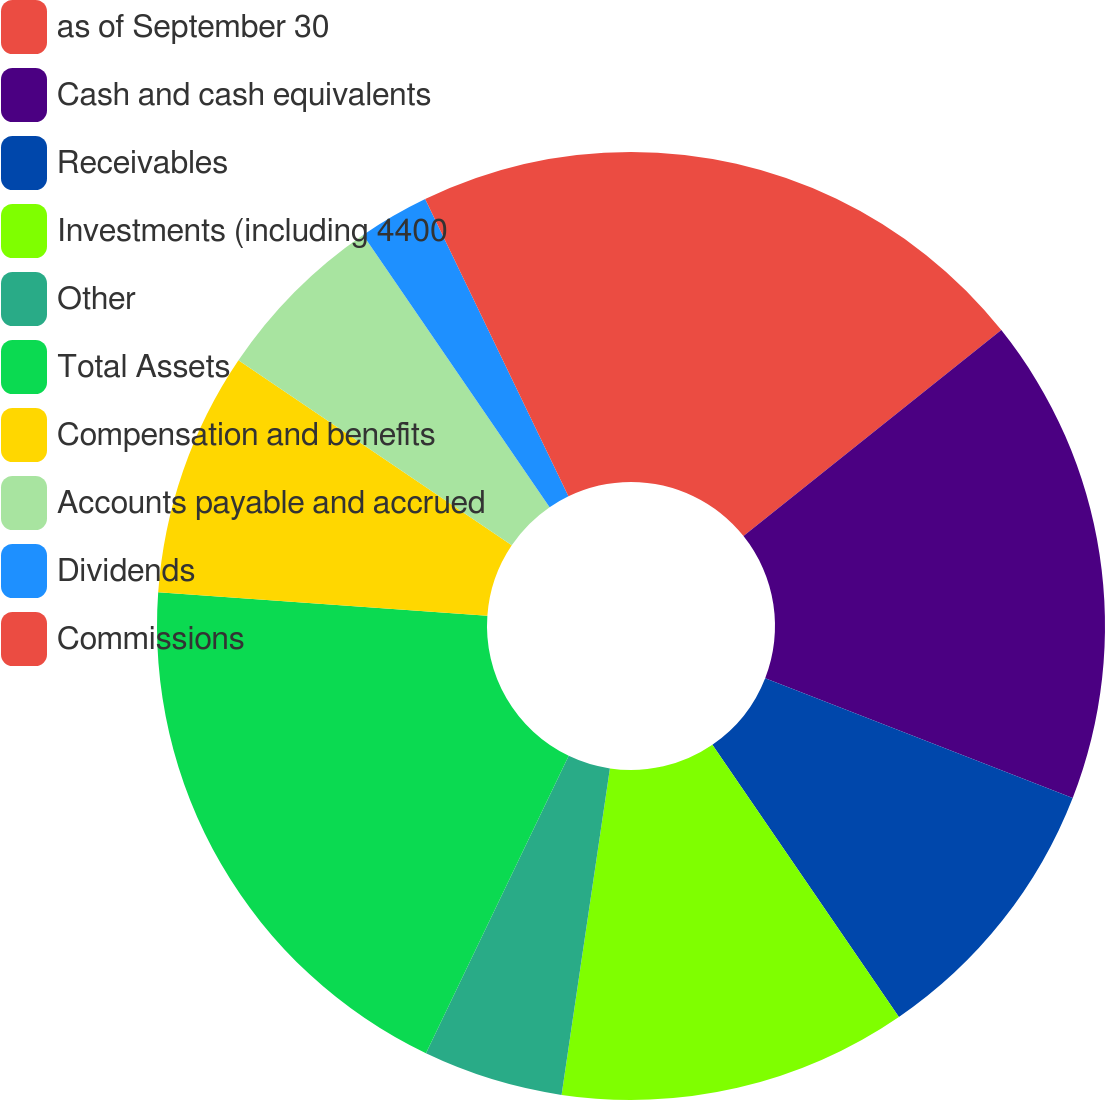Convert chart to OTSL. <chart><loc_0><loc_0><loc_500><loc_500><pie_chart><fcel>as of September 30<fcel>Cash and cash equivalents<fcel>Receivables<fcel>Investments (including 4400<fcel>Other<fcel>Total Assets<fcel>Compensation and benefits<fcel>Accounts payable and accrued<fcel>Dividends<fcel>Commissions<nl><fcel>14.27%<fcel>16.64%<fcel>9.53%<fcel>11.9%<fcel>4.78%<fcel>19.01%<fcel>8.34%<fcel>5.97%<fcel>2.41%<fcel>7.15%<nl></chart> 